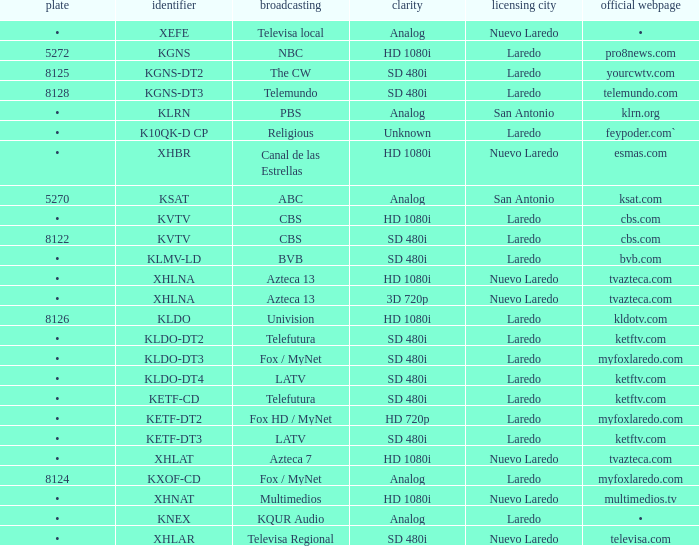Name the city of license with resolution of sd 480i and official website of telemundo.com Laredo. 